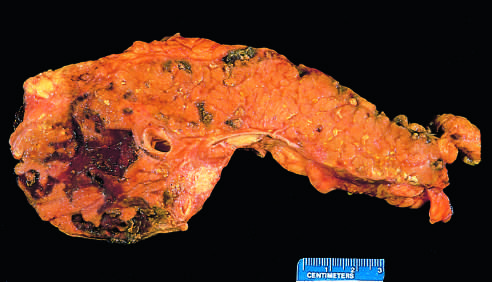has the pancreas been sectioned longitudinally to reveal dark areas of hemorrhage in the pancreatic substance and a focal area of pale fat necrosis in the peripancreatic fat upper left?
Answer the question using a single word or phrase. Yes 